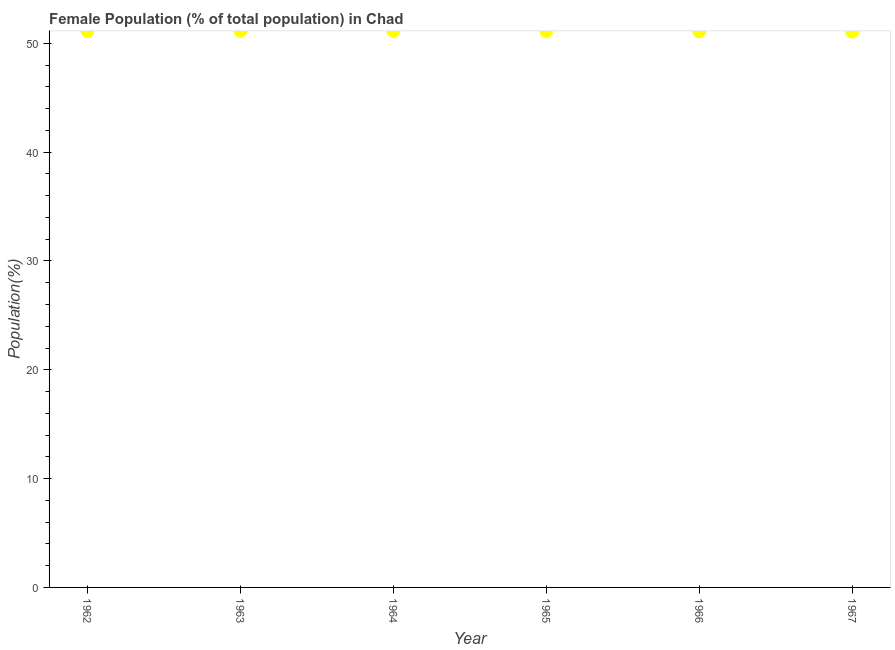What is the female population in 1967?
Offer a very short reply. 51.08. Across all years, what is the maximum female population?
Your answer should be compact. 51.14. Across all years, what is the minimum female population?
Provide a succinct answer. 51.08. In which year was the female population minimum?
Provide a short and direct response. 1967. What is the sum of the female population?
Your answer should be very brief. 306.72. What is the difference between the female population in 1962 and 1967?
Your answer should be very brief. 0.06. What is the average female population per year?
Offer a very short reply. 51.12. What is the median female population?
Provide a short and direct response. 51.13. In how many years, is the female population greater than 44 %?
Offer a very short reply. 6. What is the ratio of the female population in 1962 to that in 1967?
Your answer should be very brief. 1. Is the female population in 1964 less than that in 1965?
Offer a terse response. No. Is the difference between the female population in 1965 and 1967 greater than the difference between any two years?
Your answer should be compact. No. What is the difference between the highest and the second highest female population?
Offer a terse response. 0. Is the sum of the female population in 1964 and 1965 greater than the maximum female population across all years?
Provide a short and direct response. Yes. What is the difference between the highest and the lowest female population?
Your answer should be very brief. 0.06. Does the female population monotonically increase over the years?
Your response must be concise. No. What is the difference between two consecutive major ticks on the Y-axis?
Provide a succinct answer. 10. Does the graph contain grids?
Provide a short and direct response. No. What is the title of the graph?
Provide a succinct answer. Female Population (% of total population) in Chad. What is the label or title of the X-axis?
Offer a terse response. Year. What is the label or title of the Y-axis?
Keep it short and to the point. Population(%). What is the Population(%) in 1962?
Offer a terse response. 51.14. What is the Population(%) in 1963?
Keep it short and to the point. 51.14. What is the Population(%) in 1964?
Give a very brief answer. 51.13. What is the Population(%) in 1965?
Your answer should be very brief. 51.12. What is the Population(%) in 1966?
Your answer should be compact. 51.1. What is the Population(%) in 1967?
Give a very brief answer. 51.08. What is the difference between the Population(%) in 1962 and 1963?
Provide a short and direct response. 0. What is the difference between the Population(%) in 1962 and 1964?
Make the answer very short. 0.01. What is the difference between the Population(%) in 1962 and 1965?
Offer a terse response. 0.02. What is the difference between the Population(%) in 1962 and 1966?
Offer a terse response. 0.04. What is the difference between the Population(%) in 1962 and 1967?
Keep it short and to the point. 0.06. What is the difference between the Population(%) in 1963 and 1964?
Offer a terse response. 0.01. What is the difference between the Population(%) in 1963 and 1965?
Offer a very short reply. 0.02. What is the difference between the Population(%) in 1963 and 1966?
Your answer should be compact. 0.04. What is the difference between the Population(%) in 1963 and 1967?
Keep it short and to the point. 0.06. What is the difference between the Population(%) in 1964 and 1965?
Your answer should be compact. 0.01. What is the difference between the Population(%) in 1964 and 1966?
Make the answer very short. 0.03. What is the difference between the Population(%) in 1964 and 1967?
Your answer should be compact. 0.06. What is the difference between the Population(%) in 1965 and 1966?
Offer a very short reply. 0.02. What is the difference between the Population(%) in 1965 and 1967?
Your answer should be compact. 0.04. What is the difference between the Population(%) in 1966 and 1967?
Offer a terse response. 0.02. What is the ratio of the Population(%) in 1962 to that in 1963?
Keep it short and to the point. 1. What is the ratio of the Population(%) in 1962 to that in 1965?
Your response must be concise. 1. What is the ratio of the Population(%) in 1962 to that in 1966?
Offer a very short reply. 1. What is the ratio of the Population(%) in 1962 to that in 1967?
Provide a short and direct response. 1. What is the ratio of the Population(%) in 1963 to that in 1966?
Keep it short and to the point. 1. What is the ratio of the Population(%) in 1964 to that in 1965?
Your answer should be compact. 1. What is the ratio of the Population(%) in 1964 to that in 1966?
Provide a short and direct response. 1. What is the ratio of the Population(%) in 1964 to that in 1967?
Ensure brevity in your answer.  1. What is the ratio of the Population(%) in 1966 to that in 1967?
Offer a terse response. 1. 